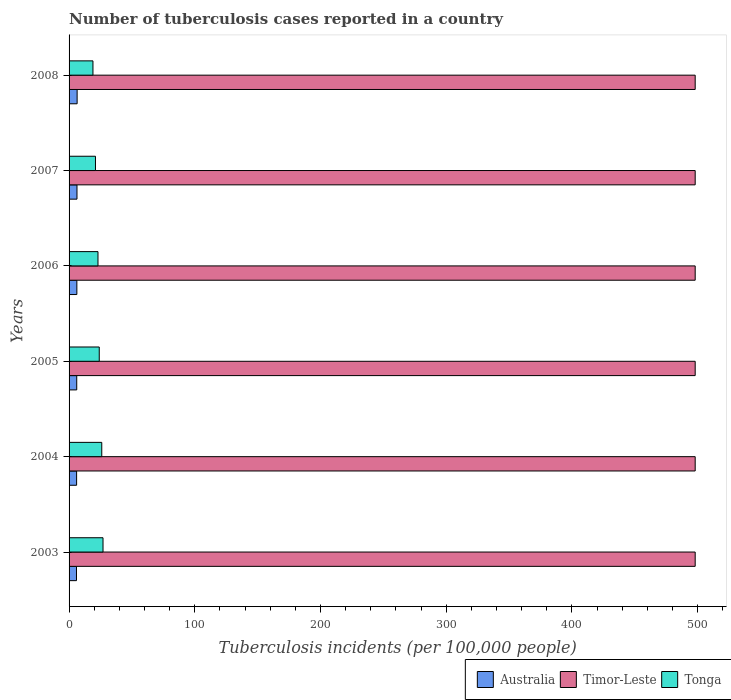How many groups of bars are there?
Ensure brevity in your answer.  6. Are the number of bars per tick equal to the number of legend labels?
Offer a terse response. Yes. Are the number of bars on each tick of the Y-axis equal?
Ensure brevity in your answer.  Yes. How many bars are there on the 6th tick from the bottom?
Your answer should be very brief. 3. What is the label of the 3rd group of bars from the top?
Your answer should be very brief. 2006. What is the number of tuberculosis cases reported in in Timor-Leste in 2005?
Provide a short and direct response. 498. Across all years, what is the maximum number of tuberculosis cases reported in in Australia?
Your answer should be very brief. 6.4. Across all years, what is the minimum number of tuberculosis cases reported in in Timor-Leste?
Make the answer very short. 498. In which year was the number of tuberculosis cases reported in in Tonga maximum?
Your answer should be compact. 2003. What is the total number of tuberculosis cases reported in in Tonga in the graph?
Ensure brevity in your answer.  140. What is the difference between the number of tuberculosis cases reported in in Timor-Leste in 2004 and that in 2008?
Provide a succinct answer. 0. What is the difference between the number of tuberculosis cases reported in in Tonga in 2004 and the number of tuberculosis cases reported in in Timor-Leste in 2006?
Offer a terse response. -472. What is the average number of tuberculosis cases reported in in Tonga per year?
Make the answer very short. 23.33. In the year 2008, what is the difference between the number of tuberculosis cases reported in in Timor-Leste and number of tuberculosis cases reported in in Tonga?
Your answer should be compact. 479. In how many years, is the number of tuberculosis cases reported in in Tonga greater than 460 ?
Your answer should be very brief. 0. What is the ratio of the number of tuberculosis cases reported in in Tonga in 2003 to that in 2008?
Keep it short and to the point. 1.42. Is the difference between the number of tuberculosis cases reported in in Timor-Leste in 2006 and 2008 greater than the difference between the number of tuberculosis cases reported in in Tonga in 2006 and 2008?
Offer a terse response. No. What is the difference between the highest and the second highest number of tuberculosis cases reported in in Australia?
Offer a very short reply. 0.1. In how many years, is the number of tuberculosis cases reported in in Australia greater than the average number of tuberculosis cases reported in in Australia taken over all years?
Keep it short and to the point. 3. Is the sum of the number of tuberculosis cases reported in in Timor-Leste in 2005 and 2006 greater than the maximum number of tuberculosis cases reported in in Australia across all years?
Your answer should be very brief. Yes. What does the 1st bar from the top in 2005 represents?
Give a very brief answer. Tonga. What does the 3rd bar from the bottom in 2006 represents?
Ensure brevity in your answer.  Tonga. How many years are there in the graph?
Your answer should be very brief. 6. What is the difference between two consecutive major ticks on the X-axis?
Offer a very short reply. 100. Does the graph contain grids?
Give a very brief answer. No. Where does the legend appear in the graph?
Give a very brief answer. Bottom right. How many legend labels are there?
Make the answer very short. 3. What is the title of the graph?
Provide a short and direct response. Number of tuberculosis cases reported in a country. What is the label or title of the X-axis?
Your answer should be very brief. Tuberculosis incidents (per 100,0 people). What is the label or title of the Y-axis?
Your response must be concise. Years. What is the Tuberculosis incidents (per 100,000 people) in Timor-Leste in 2003?
Your response must be concise. 498. What is the Tuberculosis incidents (per 100,000 people) of Tonga in 2003?
Ensure brevity in your answer.  27. What is the Tuberculosis incidents (per 100,000 people) of Australia in 2004?
Your answer should be very brief. 6. What is the Tuberculosis incidents (per 100,000 people) in Timor-Leste in 2004?
Your answer should be compact. 498. What is the Tuberculosis incidents (per 100,000 people) in Tonga in 2004?
Give a very brief answer. 26. What is the Tuberculosis incidents (per 100,000 people) in Timor-Leste in 2005?
Ensure brevity in your answer.  498. What is the Tuberculosis incidents (per 100,000 people) of Australia in 2006?
Your response must be concise. 6.2. What is the Tuberculosis incidents (per 100,000 people) in Timor-Leste in 2006?
Provide a succinct answer. 498. What is the Tuberculosis incidents (per 100,000 people) of Australia in 2007?
Provide a short and direct response. 6.3. What is the Tuberculosis incidents (per 100,000 people) in Timor-Leste in 2007?
Provide a short and direct response. 498. What is the Tuberculosis incidents (per 100,000 people) of Tonga in 2007?
Provide a succinct answer. 21. What is the Tuberculosis incidents (per 100,000 people) in Australia in 2008?
Offer a very short reply. 6.4. What is the Tuberculosis incidents (per 100,000 people) of Timor-Leste in 2008?
Offer a terse response. 498. Across all years, what is the maximum Tuberculosis incidents (per 100,000 people) in Timor-Leste?
Your response must be concise. 498. Across all years, what is the minimum Tuberculosis incidents (per 100,000 people) of Australia?
Give a very brief answer. 5.9. Across all years, what is the minimum Tuberculosis incidents (per 100,000 people) in Timor-Leste?
Ensure brevity in your answer.  498. What is the total Tuberculosis incidents (per 100,000 people) in Australia in the graph?
Provide a short and direct response. 36.9. What is the total Tuberculosis incidents (per 100,000 people) in Timor-Leste in the graph?
Provide a short and direct response. 2988. What is the total Tuberculosis incidents (per 100,000 people) of Tonga in the graph?
Make the answer very short. 140. What is the difference between the Tuberculosis incidents (per 100,000 people) in Australia in 2003 and that in 2005?
Provide a short and direct response. -0.2. What is the difference between the Tuberculosis incidents (per 100,000 people) of Tonga in 2003 and that in 2005?
Keep it short and to the point. 3. What is the difference between the Tuberculosis incidents (per 100,000 people) of Australia in 2003 and that in 2006?
Keep it short and to the point. -0.3. What is the difference between the Tuberculosis incidents (per 100,000 people) in Australia in 2003 and that in 2007?
Your answer should be compact. -0.4. What is the difference between the Tuberculosis incidents (per 100,000 people) of Timor-Leste in 2003 and that in 2007?
Your answer should be very brief. 0. What is the difference between the Tuberculosis incidents (per 100,000 people) of Tonga in 2003 and that in 2008?
Provide a succinct answer. 8. What is the difference between the Tuberculosis incidents (per 100,000 people) in Australia in 2004 and that in 2005?
Offer a terse response. -0.1. What is the difference between the Tuberculosis incidents (per 100,000 people) in Timor-Leste in 2004 and that in 2005?
Ensure brevity in your answer.  0. What is the difference between the Tuberculosis incidents (per 100,000 people) of Tonga in 2004 and that in 2005?
Your answer should be very brief. 2. What is the difference between the Tuberculosis incidents (per 100,000 people) of Tonga in 2004 and that in 2006?
Your answer should be compact. 3. What is the difference between the Tuberculosis incidents (per 100,000 people) in Australia in 2004 and that in 2007?
Your response must be concise. -0.3. What is the difference between the Tuberculosis incidents (per 100,000 people) in Tonga in 2004 and that in 2007?
Keep it short and to the point. 5. What is the difference between the Tuberculosis incidents (per 100,000 people) in Timor-Leste in 2004 and that in 2008?
Keep it short and to the point. 0. What is the difference between the Tuberculosis incidents (per 100,000 people) of Australia in 2005 and that in 2006?
Offer a terse response. -0.1. What is the difference between the Tuberculosis incidents (per 100,000 people) in Timor-Leste in 2005 and that in 2007?
Provide a succinct answer. 0. What is the difference between the Tuberculosis incidents (per 100,000 people) of Tonga in 2005 and that in 2008?
Ensure brevity in your answer.  5. What is the difference between the Tuberculosis incidents (per 100,000 people) of Australia in 2006 and that in 2008?
Make the answer very short. -0.2. What is the difference between the Tuberculosis incidents (per 100,000 people) in Timor-Leste in 2006 and that in 2008?
Offer a terse response. 0. What is the difference between the Tuberculosis incidents (per 100,000 people) of Tonga in 2006 and that in 2008?
Offer a very short reply. 4. What is the difference between the Tuberculosis incidents (per 100,000 people) in Australia in 2007 and that in 2008?
Your response must be concise. -0.1. What is the difference between the Tuberculosis incidents (per 100,000 people) in Australia in 2003 and the Tuberculosis incidents (per 100,000 people) in Timor-Leste in 2004?
Give a very brief answer. -492.1. What is the difference between the Tuberculosis incidents (per 100,000 people) of Australia in 2003 and the Tuberculosis incidents (per 100,000 people) of Tonga in 2004?
Your answer should be compact. -20.1. What is the difference between the Tuberculosis incidents (per 100,000 people) of Timor-Leste in 2003 and the Tuberculosis incidents (per 100,000 people) of Tonga in 2004?
Make the answer very short. 472. What is the difference between the Tuberculosis incidents (per 100,000 people) in Australia in 2003 and the Tuberculosis incidents (per 100,000 people) in Timor-Leste in 2005?
Offer a very short reply. -492.1. What is the difference between the Tuberculosis incidents (per 100,000 people) in Australia in 2003 and the Tuberculosis incidents (per 100,000 people) in Tonga in 2005?
Make the answer very short. -18.1. What is the difference between the Tuberculosis incidents (per 100,000 people) in Timor-Leste in 2003 and the Tuberculosis incidents (per 100,000 people) in Tonga in 2005?
Your response must be concise. 474. What is the difference between the Tuberculosis incidents (per 100,000 people) of Australia in 2003 and the Tuberculosis incidents (per 100,000 people) of Timor-Leste in 2006?
Your response must be concise. -492.1. What is the difference between the Tuberculosis incidents (per 100,000 people) of Australia in 2003 and the Tuberculosis incidents (per 100,000 people) of Tonga in 2006?
Your response must be concise. -17.1. What is the difference between the Tuberculosis incidents (per 100,000 people) of Timor-Leste in 2003 and the Tuberculosis incidents (per 100,000 people) of Tonga in 2006?
Provide a succinct answer. 475. What is the difference between the Tuberculosis incidents (per 100,000 people) in Australia in 2003 and the Tuberculosis incidents (per 100,000 people) in Timor-Leste in 2007?
Ensure brevity in your answer.  -492.1. What is the difference between the Tuberculosis incidents (per 100,000 people) in Australia in 2003 and the Tuberculosis incidents (per 100,000 people) in Tonga in 2007?
Keep it short and to the point. -15.1. What is the difference between the Tuberculosis incidents (per 100,000 people) in Timor-Leste in 2003 and the Tuberculosis incidents (per 100,000 people) in Tonga in 2007?
Keep it short and to the point. 477. What is the difference between the Tuberculosis incidents (per 100,000 people) in Australia in 2003 and the Tuberculosis incidents (per 100,000 people) in Timor-Leste in 2008?
Offer a terse response. -492.1. What is the difference between the Tuberculosis incidents (per 100,000 people) of Australia in 2003 and the Tuberculosis incidents (per 100,000 people) of Tonga in 2008?
Offer a terse response. -13.1. What is the difference between the Tuberculosis incidents (per 100,000 people) in Timor-Leste in 2003 and the Tuberculosis incidents (per 100,000 people) in Tonga in 2008?
Provide a succinct answer. 479. What is the difference between the Tuberculosis incidents (per 100,000 people) in Australia in 2004 and the Tuberculosis incidents (per 100,000 people) in Timor-Leste in 2005?
Make the answer very short. -492. What is the difference between the Tuberculosis incidents (per 100,000 people) in Australia in 2004 and the Tuberculosis incidents (per 100,000 people) in Tonga in 2005?
Provide a succinct answer. -18. What is the difference between the Tuberculosis incidents (per 100,000 people) in Timor-Leste in 2004 and the Tuberculosis incidents (per 100,000 people) in Tonga in 2005?
Offer a very short reply. 474. What is the difference between the Tuberculosis incidents (per 100,000 people) in Australia in 2004 and the Tuberculosis incidents (per 100,000 people) in Timor-Leste in 2006?
Ensure brevity in your answer.  -492. What is the difference between the Tuberculosis incidents (per 100,000 people) in Australia in 2004 and the Tuberculosis incidents (per 100,000 people) in Tonga in 2006?
Give a very brief answer. -17. What is the difference between the Tuberculosis incidents (per 100,000 people) of Timor-Leste in 2004 and the Tuberculosis incidents (per 100,000 people) of Tonga in 2006?
Make the answer very short. 475. What is the difference between the Tuberculosis incidents (per 100,000 people) of Australia in 2004 and the Tuberculosis incidents (per 100,000 people) of Timor-Leste in 2007?
Your response must be concise. -492. What is the difference between the Tuberculosis incidents (per 100,000 people) of Australia in 2004 and the Tuberculosis incidents (per 100,000 people) of Tonga in 2007?
Offer a terse response. -15. What is the difference between the Tuberculosis incidents (per 100,000 people) in Timor-Leste in 2004 and the Tuberculosis incidents (per 100,000 people) in Tonga in 2007?
Provide a succinct answer. 477. What is the difference between the Tuberculosis incidents (per 100,000 people) in Australia in 2004 and the Tuberculosis incidents (per 100,000 people) in Timor-Leste in 2008?
Your answer should be very brief. -492. What is the difference between the Tuberculosis incidents (per 100,000 people) of Timor-Leste in 2004 and the Tuberculosis incidents (per 100,000 people) of Tonga in 2008?
Give a very brief answer. 479. What is the difference between the Tuberculosis incidents (per 100,000 people) of Australia in 2005 and the Tuberculosis incidents (per 100,000 people) of Timor-Leste in 2006?
Provide a short and direct response. -491.9. What is the difference between the Tuberculosis incidents (per 100,000 people) in Australia in 2005 and the Tuberculosis incidents (per 100,000 people) in Tonga in 2006?
Your response must be concise. -16.9. What is the difference between the Tuberculosis incidents (per 100,000 people) in Timor-Leste in 2005 and the Tuberculosis incidents (per 100,000 people) in Tonga in 2006?
Your answer should be very brief. 475. What is the difference between the Tuberculosis incidents (per 100,000 people) in Australia in 2005 and the Tuberculosis incidents (per 100,000 people) in Timor-Leste in 2007?
Provide a short and direct response. -491.9. What is the difference between the Tuberculosis incidents (per 100,000 people) of Australia in 2005 and the Tuberculosis incidents (per 100,000 people) of Tonga in 2007?
Offer a very short reply. -14.9. What is the difference between the Tuberculosis incidents (per 100,000 people) in Timor-Leste in 2005 and the Tuberculosis incidents (per 100,000 people) in Tonga in 2007?
Provide a short and direct response. 477. What is the difference between the Tuberculosis incidents (per 100,000 people) in Australia in 2005 and the Tuberculosis incidents (per 100,000 people) in Timor-Leste in 2008?
Your response must be concise. -491.9. What is the difference between the Tuberculosis incidents (per 100,000 people) of Timor-Leste in 2005 and the Tuberculosis incidents (per 100,000 people) of Tonga in 2008?
Provide a short and direct response. 479. What is the difference between the Tuberculosis incidents (per 100,000 people) of Australia in 2006 and the Tuberculosis incidents (per 100,000 people) of Timor-Leste in 2007?
Make the answer very short. -491.8. What is the difference between the Tuberculosis incidents (per 100,000 people) of Australia in 2006 and the Tuberculosis incidents (per 100,000 people) of Tonga in 2007?
Give a very brief answer. -14.8. What is the difference between the Tuberculosis incidents (per 100,000 people) in Timor-Leste in 2006 and the Tuberculosis incidents (per 100,000 people) in Tonga in 2007?
Your answer should be very brief. 477. What is the difference between the Tuberculosis incidents (per 100,000 people) in Australia in 2006 and the Tuberculosis incidents (per 100,000 people) in Timor-Leste in 2008?
Provide a short and direct response. -491.8. What is the difference between the Tuberculosis incidents (per 100,000 people) in Timor-Leste in 2006 and the Tuberculosis incidents (per 100,000 people) in Tonga in 2008?
Your answer should be very brief. 479. What is the difference between the Tuberculosis incidents (per 100,000 people) in Australia in 2007 and the Tuberculosis incidents (per 100,000 people) in Timor-Leste in 2008?
Give a very brief answer. -491.7. What is the difference between the Tuberculosis incidents (per 100,000 people) of Timor-Leste in 2007 and the Tuberculosis incidents (per 100,000 people) of Tonga in 2008?
Keep it short and to the point. 479. What is the average Tuberculosis incidents (per 100,000 people) of Australia per year?
Make the answer very short. 6.15. What is the average Tuberculosis incidents (per 100,000 people) in Timor-Leste per year?
Your answer should be very brief. 498. What is the average Tuberculosis incidents (per 100,000 people) in Tonga per year?
Offer a terse response. 23.33. In the year 2003, what is the difference between the Tuberculosis incidents (per 100,000 people) of Australia and Tuberculosis incidents (per 100,000 people) of Timor-Leste?
Your response must be concise. -492.1. In the year 2003, what is the difference between the Tuberculosis incidents (per 100,000 people) of Australia and Tuberculosis incidents (per 100,000 people) of Tonga?
Offer a terse response. -21.1. In the year 2003, what is the difference between the Tuberculosis incidents (per 100,000 people) of Timor-Leste and Tuberculosis incidents (per 100,000 people) of Tonga?
Give a very brief answer. 471. In the year 2004, what is the difference between the Tuberculosis incidents (per 100,000 people) in Australia and Tuberculosis incidents (per 100,000 people) in Timor-Leste?
Make the answer very short. -492. In the year 2004, what is the difference between the Tuberculosis incidents (per 100,000 people) of Timor-Leste and Tuberculosis incidents (per 100,000 people) of Tonga?
Make the answer very short. 472. In the year 2005, what is the difference between the Tuberculosis incidents (per 100,000 people) of Australia and Tuberculosis incidents (per 100,000 people) of Timor-Leste?
Make the answer very short. -491.9. In the year 2005, what is the difference between the Tuberculosis incidents (per 100,000 people) of Australia and Tuberculosis incidents (per 100,000 people) of Tonga?
Provide a short and direct response. -17.9. In the year 2005, what is the difference between the Tuberculosis incidents (per 100,000 people) of Timor-Leste and Tuberculosis incidents (per 100,000 people) of Tonga?
Provide a short and direct response. 474. In the year 2006, what is the difference between the Tuberculosis incidents (per 100,000 people) of Australia and Tuberculosis incidents (per 100,000 people) of Timor-Leste?
Provide a short and direct response. -491.8. In the year 2006, what is the difference between the Tuberculosis incidents (per 100,000 people) of Australia and Tuberculosis incidents (per 100,000 people) of Tonga?
Provide a short and direct response. -16.8. In the year 2006, what is the difference between the Tuberculosis incidents (per 100,000 people) of Timor-Leste and Tuberculosis incidents (per 100,000 people) of Tonga?
Give a very brief answer. 475. In the year 2007, what is the difference between the Tuberculosis incidents (per 100,000 people) of Australia and Tuberculosis incidents (per 100,000 people) of Timor-Leste?
Offer a terse response. -491.7. In the year 2007, what is the difference between the Tuberculosis incidents (per 100,000 people) of Australia and Tuberculosis incidents (per 100,000 people) of Tonga?
Keep it short and to the point. -14.7. In the year 2007, what is the difference between the Tuberculosis incidents (per 100,000 people) of Timor-Leste and Tuberculosis incidents (per 100,000 people) of Tonga?
Make the answer very short. 477. In the year 2008, what is the difference between the Tuberculosis incidents (per 100,000 people) in Australia and Tuberculosis incidents (per 100,000 people) in Timor-Leste?
Offer a terse response. -491.6. In the year 2008, what is the difference between the Tuberculosis incidents (per 100,000 people) of Timor-Leste and Tuberculosis incidents (per 100,000 people) of Tonga?
Ensure brevity in your answer.  479. What is the ratio of the Tuberculosis incidents (per 100,000 people) of Australia in 2003 to that in 2004?
Make the answer very short. 0.98. What is the ratio of the Tuberculosis incidents (per 100,000 people) in Tonga in 2003 to that in 2004?
Ensure brevity in your answer.  1.04. What is the ratio of the Tuberculosis incidents (per 100,000 people) in Australia in 2003 to that in 2005?
Give a very brief answer. 0.97. What is the ratio of the Tuberculosis incidents (per 100,000 people) in Tonga in 2003 to that in 2005?
Offer a terse response. 1.12. What is the ratio of the Tuberculosis incidents (per 100,000 people) of Australia in 2003 to that in 2006?
Keep it short and to the point. 0.95. What is the ratio of the Tuberculosis incidents (per 100,000 people) in Tonga in 2003 to that in 2006?
Keep it short and to the point. 1.17. What is the ratio of the Tuberculosis incidents (per 100,000 people) of Australia in 2003 to that in 2007?
Offer a very short reply. 0.94. What is the ratio of the Tuberculosis incidents (per 100,000 people) in Tonga in 2003 to that in 2007?
Provide a short and direct response. 1.29. What is the ratio of the Tuberculosis incidents (per 100,000 people) in Australia in 2003 to that in 2008?
Keep it short and to the point. 0.92. What is the ratio of the Tuberculosis incidents (per 100,000 people) of Timor-Leste in 2003 to that in 2008?
Keep it short and to the point. 1. What is the ratio of the Tuberculosis incidents (per 100,000 people) of Tonga in 2003 to that in 2008?
Give a very brief answer. 1.42. What is the ratio of the Tuberculosis incidents (per 100,000 people) in Australia in 2004 to that in 2005?
Offer a very short reply. 0.98. What is the ratio of the Tuberculosis incidents (per 100,000 people) of Timor-Leste in 2004 to that in 2005?
Provide a succinct answer. 1. What is the ratio of the Tuberculosis incidents (per 100,000 people) of Tonga in 2004 to that in 2005?
Ensure brevity in your answer.  1.08. What is the ratio of the Tuberculosis incidents (per 100,000 people) in Australia in 2004 to that in 2006?
Your answer should be very brief. 0.97. What is the ratio of the Tuberculosis incidents (per 100,000 people) of Timor-Leste in 2004 to that in 2006?
Your response must be concise. 1. What is the ratio of the Tuberculosis incidents (per 100,000 people) in Tonga in 2004 to that in 2006?
Provide a succinct answer. 1.13. What is the ratio of the Tuberculosis incidents (per 100,000 people) of Australia in 2004 to that in 2007?
Ensure brevity in your answer.  0.95. What is the ratio of the Tuberculosis incidents (per 100,000 people) in Timor-Leste in 2004 to that in 2007?
Your answer should be very brief. 1. What is the ratio of the Tuberculosis incidents (per 100,000 people) in Tonga in 2004 to that in 2007?
Give a very brief answer. 1.24. What is the ratio of the Tuberculosis incidents (per 100,000 people) in Timor-Leste in 2004 to that in 2008?
Offer a very short reply. 1. What is the ratio of the Tuberculosis incidents (per 100,000 people) in Tonga in 2004 to that in 2008?
Offer a terse response. 1.37. What is the ratio of the Tuberculosis incidents (per 100,000 people) of Australia in 2005 to that in 2006?
Offer a terse response. 0.98. What is the ratio of the Tuberculosis incidents (per 100,000 people) of Timor-Leste in 2005 to that in 2006?
Ensure brevity in your answer.  1. What is the ratio of the Tuberculosis incidents (per 100,000 people) in Tonga in 2005 to that in 2006?
Provide a short and direct response. 1.04. What is the ratio of the Tuberculosis incidents (per 100,000 people) of Australia in 2005 to that in 2007?
Ensure brevity in your answer.  0.97. What is the ratio of the Tuberculosis incidents (per 100,000 people) in Timor-Leste in 2005 to that in 2007?
Offer a terse response. 1. What is the ratio of the Tuberculosis incidents (per 100,000 people) in Tonga in 2005 to that in 2007?
Offer a terse response. 1.14. What is the ratio of the Tuberculosis incidents (per 100,000 people) of Australia in 2005 to that in 2008?
Offer a very short reply. 0.95. What is the ratio of the Tuberculosis incidents (per 100,000 people) in Tonga in 2005 to that in 2008?
Offer a terse response. 1.26. What is the ratio of the Tuberculosis incidents (per 100,000 people) of Australia in 2006 to that in 2007?
Your answer should be compact. 0.98. What is the ratio of the Tuberculosis incidents (per 100,000 people) of Tonga in 2006 to that in 2007?
Keep it short and to the point. 1.1. What is the ratio of the Tuberculosis incidents (per 100,000 people) in Australia in 2006 to that in 2008?
Ensure brevity in your answer.  0.97. What is the ratio of the Tuberculosis incidents (per 100,000 people) of Timor-Leste in 2006 to that in 2008?
Ensure brevity in your answer.  1. What is the ratio of the Tuberculosis incidents (per 100,000 people) of Tonga in 2006 to that in 2008?
Keep it short and to the point. 1.21. What is the ratio of the Tuberculosis incidents (per 100,000 people) of Australia in 2007 to that in 2008?
Ensure brevity in your answer.  0.98. What is the ratio of the Tuberculosis incidents (per 100,000 people) of Tonga in 2007 to that in 2008?
Offer a terse response. 1.11. What is the difference between the highest and the second highest Tuberculosis incidents (per 100,000 people) of Timor-Leste?
Ensure brevity in your answer.  0. What is the difference between the highest and the lowest Tuberculosis incidents (per 100,000 people) in Timor-Leste?
Your answer should be very brief. 0. What is the difference between the highest and the lowest Tuberculosis incidents (per 100,000 people) in Tonga?
Your answer should be very brief. 8. 